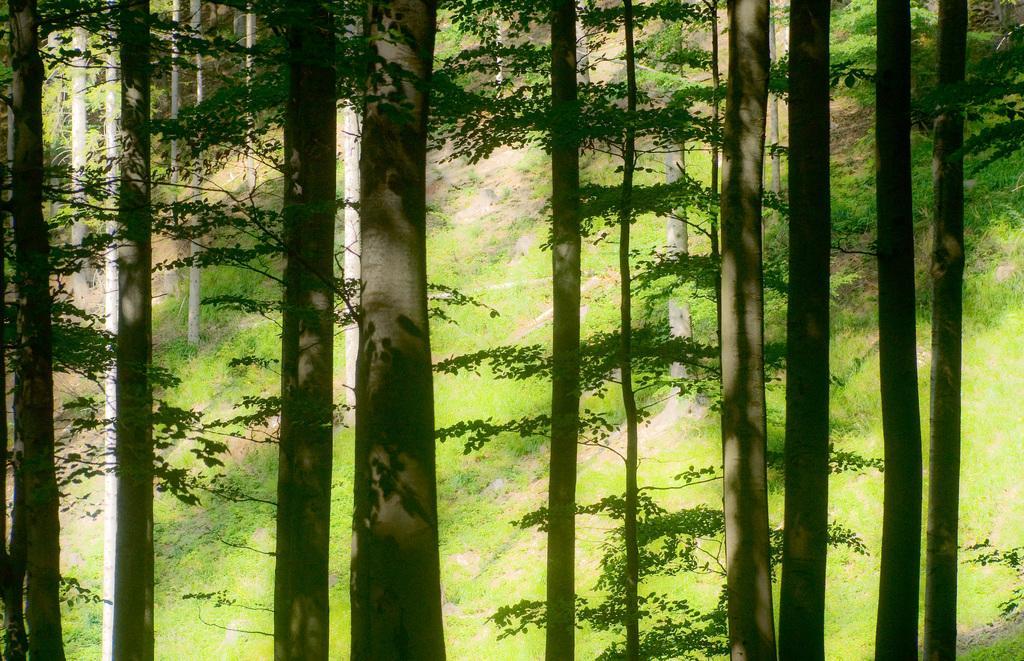Can you describe this image briefly? In the image we can see some trees and grass. 